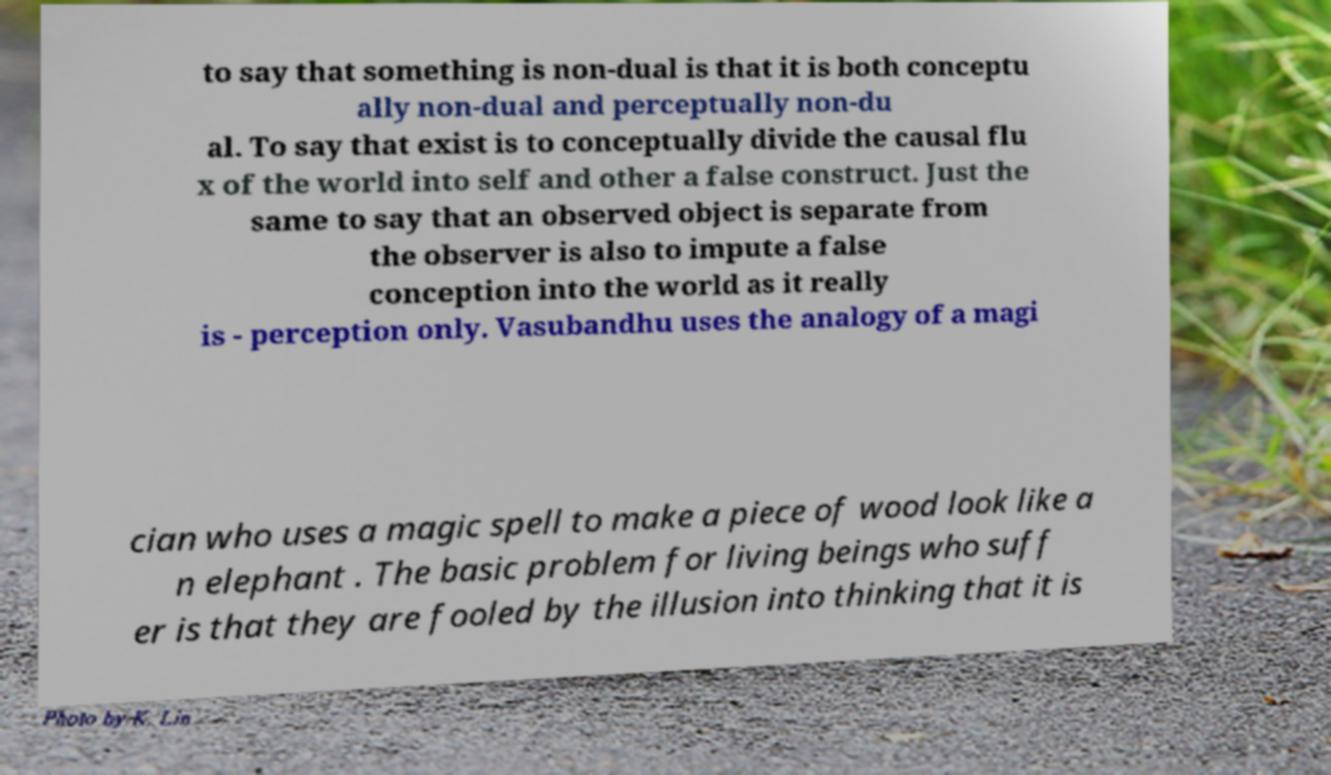Please read and relay the text visible in this image. What does it say? to say that something is non-dual is that it is both conceptu ally non-dual and perceptually non-du al. To say that exist is to conceptually divide the causal flu x of the world into self and other a false construct. Just the same to say that an observed object is separate from the observer is also to impute a false conception into the world as it really is - perception only. Vasubandhu uses the analogy of a magi cian who uses a magic spell to make a piece of wood look like a n elephant . The basic problem for living beings who suff er is that they are fooled by the illusion into thinking that it is 